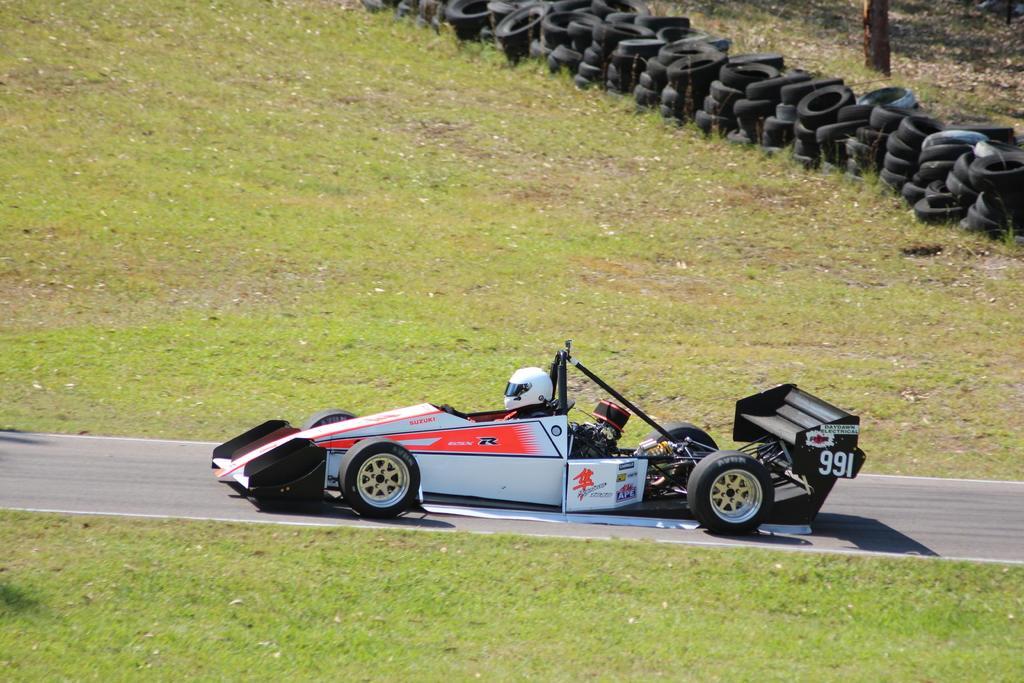How would you summarize this image in a sentence or two? This picture shows a sports car and we see human seated and we see helmet on the head and we see grass on the ground and few tires on the side. 